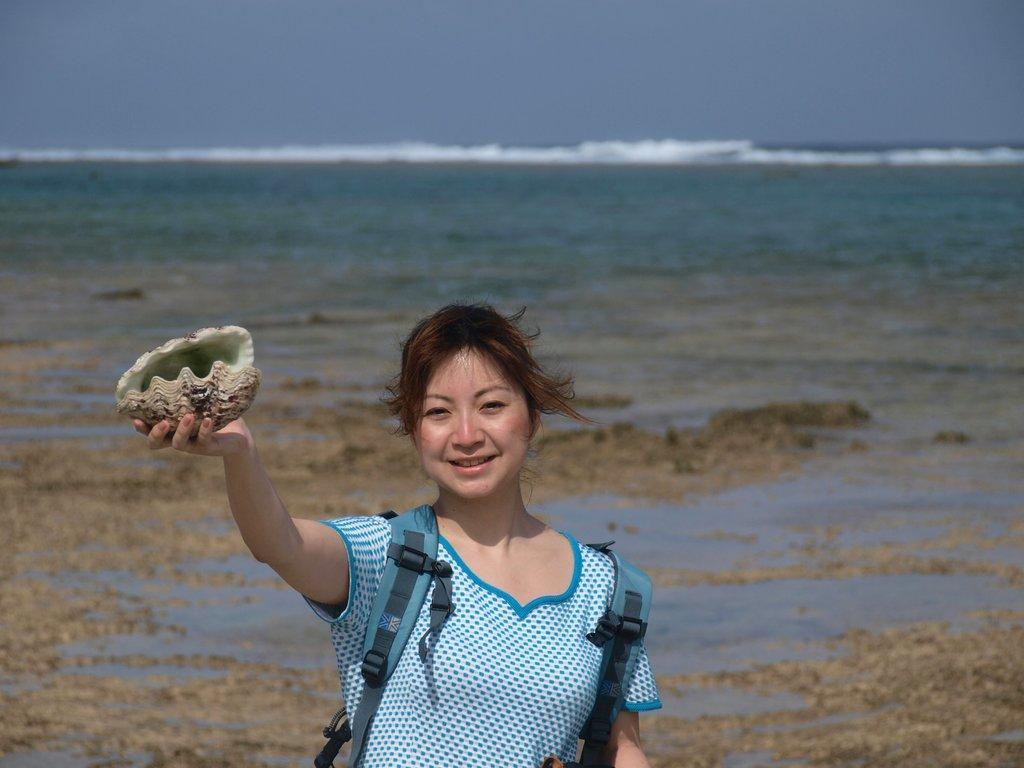Please provide a concise description of this image. In this image I can see a person standing and holding some object which is in brown and cream color and the person is wearing green color dress and green color bag. Background I can see the water and the sky is in blue color. 